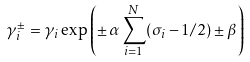Convert formula to latex. <formula><loc_0><loc_0><loc_500><loc_500>\gamma ^ { \pm } _ { i } = \gamma _ { i } \exp \left ( \pm \, \alpha \sum _ { i = 1 } ^ { N } ( \sigma _ { i } - 1 / 2 ) \pm \beta \right )</formula> 